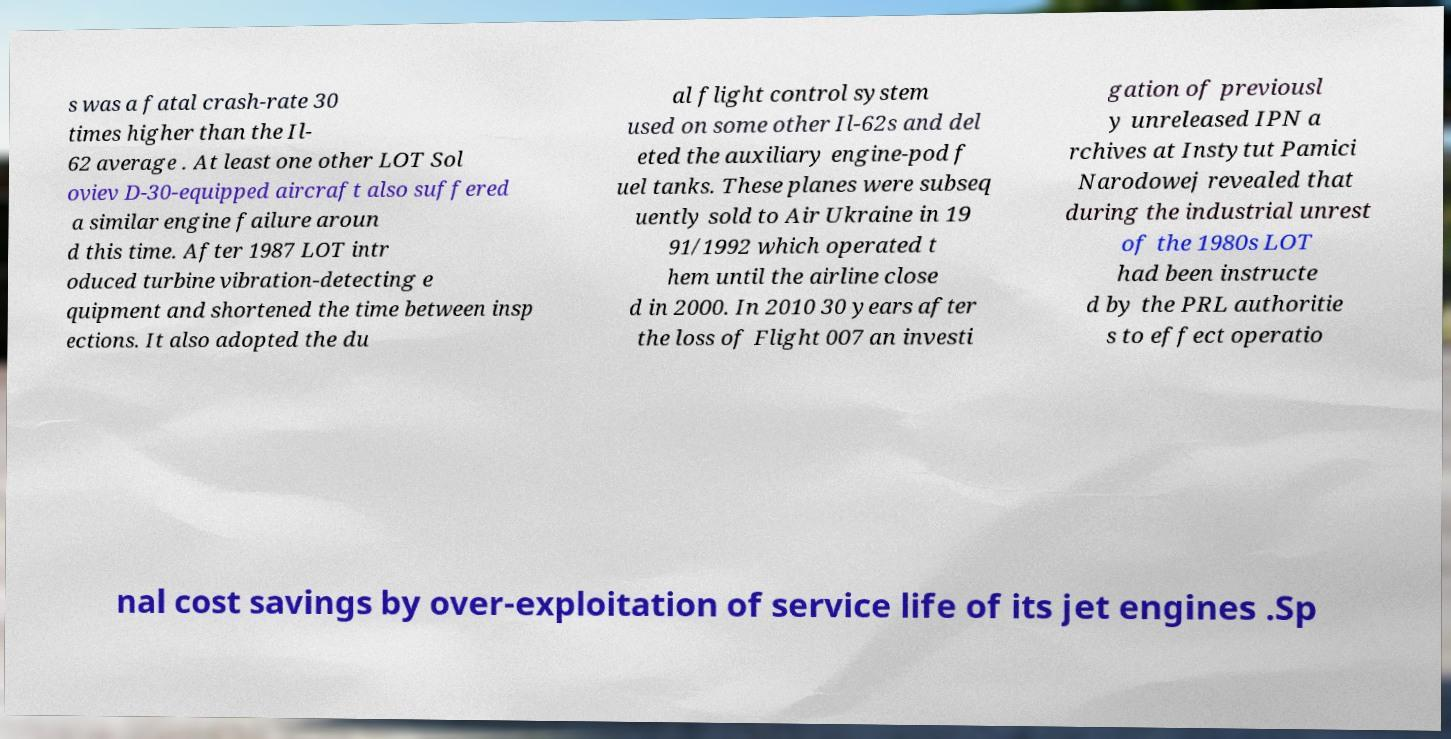Could you assist in decoding the text presented in this image and type it out clearly? s was a fatal crash-rate 30 times higher than the Il- 62 average . At least one other LOT Sol oviev D-30-equipped aircraft also suffered a similar engine failure aroun d this time. After 1987 LOT intr oduced turbine vibration-detecting e quipment and shortened the time between insp ections. It also adopted the du al flight control system used on some other Il-62s and del eted the auxiliary engine-pod f uel tanks. These planes were subseq uently sold to Air Ukraine in 19 91/1992 which operated t hem until the airline close d in 2000. In 2010 30 years after the loss of Flight 007 an investi gation of previousl y unreleased IPN a rchives at Instytut Pamici Narodowej revealed that during the industrial unrest of the 1980s LOT had been instructe d by the PRL authoritie s to effect operatio nal cost savings by over-exploitation of service life of its jet engines .Sp 